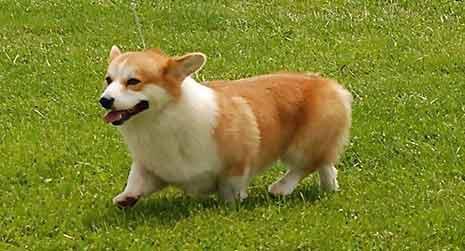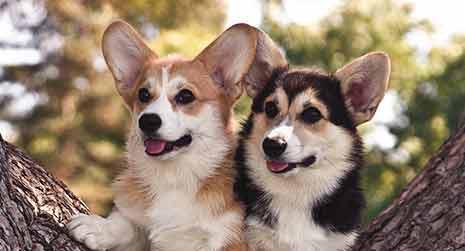The first image is the image on the left, the second image is the image on the right. Examine the images to the left and right. Is the description "The right image includes twice the number of dogs as the left image." accurate? Answer yes or no. Yes. The first image is the image on the left, the second image is the image on the right. For the images displayed, is the sentence "One image contains twice as many dogs as the other image." factually correct? Answer yes or no. Yes. The first image is the image on the left, the second image is the image on the right. Given the left and right images, does the statement "An image shows two big-eared dog faces slide-by-side." hold true? Answer yes or no. Yes. The first image is the image on the left, the second image is the image on the right. Examine the images to the left and right. Is the description "At least one dog is sitting in the grass." accurate? Answer yes or no. No. The first image is the image on the left, the second image is the image on the right. Evaluate the accuracy of this statement regarding the images: "Two corgies sit side by side in one image, while another corgi with its mouth open and tongue showing is alone in the other image.". Is it true? Answer yes or no. Yes. 